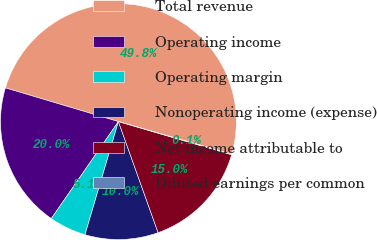Convert chart to OTSL. <chart><loc_0><loc_0><loc_500><loc_500><pie_chart><fcel>Total revenue<fcel>Operating income<fcel>Operating margin<fcel>Nonoperating income (expense)<fcel>Net income attributable to<fcel>Diluted earnings per common<nl><fcel>49.83%<fcel>19.98%<fcel>5.06%<fcel>10.03%<fcel>15.01%<fcel>0.08%<nl></chart> 